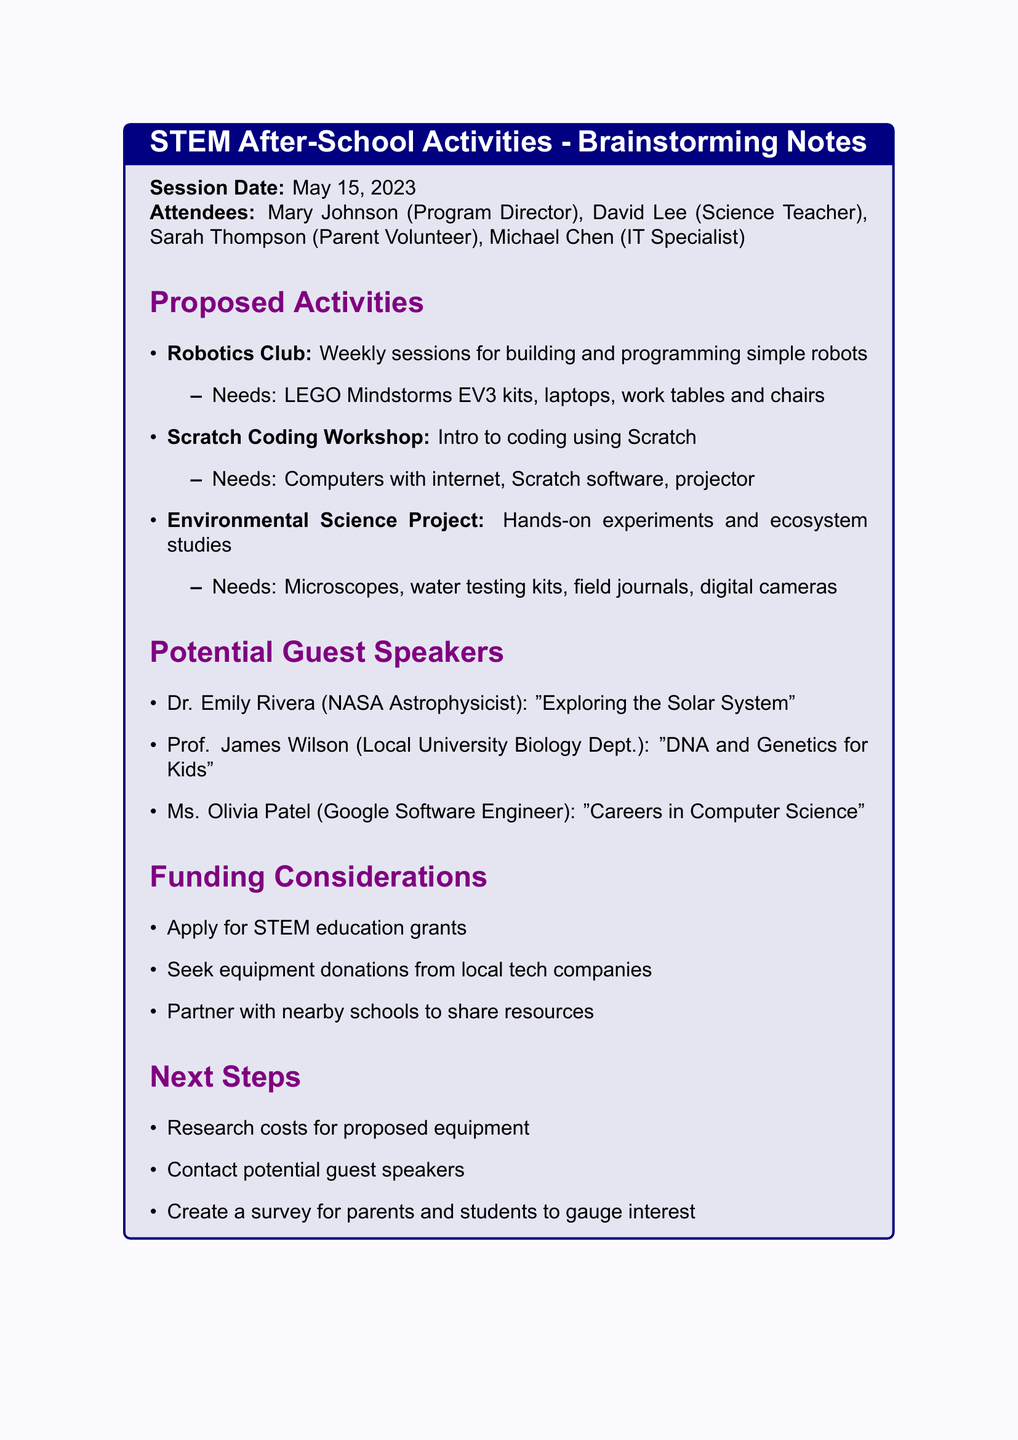What is the session date? The session date is mentioned at the top of the document, which is May 15, 2023.
Answer: May 15, 2023 Who is the Program Director? The Program Director's name is listed among the attendees, which is Mary Johnson.
Answer: Mary Johnson What is one proposed activity? The proposed activities are listed, and one of them is the Robotics Club.
Answer: Robotics Club What equipment is needed for the Scratch Coding Workshop? The equipment needs for the Scratch Coding Workshop are listed, which include computers with internet access, Scratch software, and a projector.
Answer: Computers with internet access, Scratch software, projector Who is a potential guest speaker? The document lists several potential guest speakers, and one example is Dr. Emily Rivera.
Answer: Dr. Emily Rivera What is one funding consideration? The document provides several funding considerations, including applying for STEM education grants.
Answer: Apply for STEM education grants What is the next step regarding guest speakers? The next steps include contacting potential guest speakers, as stated in the document.
Answer: Contact potential guest speakers How many proposed activities are listed? The document lists three proposed activities under the activities section.
Answer: Three 